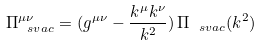<formula> <loc_0><loc_0><loc_500><loc_500>\Pi _ { \ s { v a c } } ^ { \mu \nu } = ( g ^ { \mu \nu } - \frac { k ^ { \mu } k ^ { \nu } } { k ^ { 2 } } ) \, \Pi _ { \ s { v a c } } ( k ^ { 2 } )</formula> 